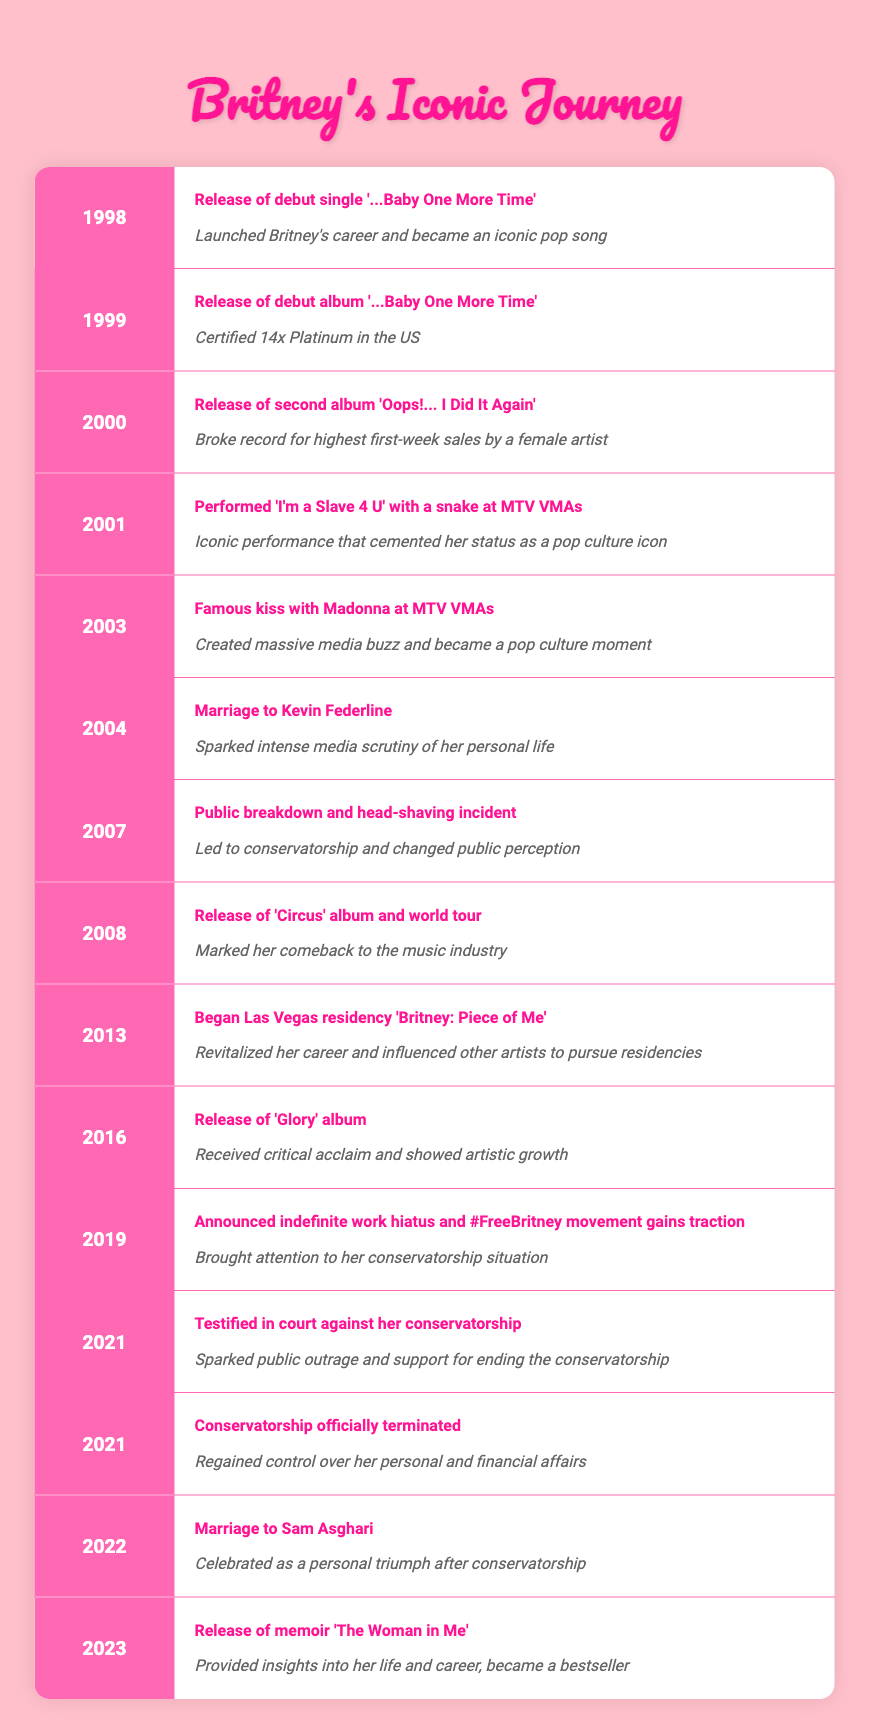What significant event marked the beginning of Britney Spears' career? The table shows that the release of her debut single '...Baby One More Time' in 1998 is cited as the event that launched her career. This information is contained in the first row of the timeline.
Answer: Release of debut single '...Baby One More Time' What was the year when Britney released her second album? According to the timeline, Britney released her second album 'Oops!... I Did It Again' in 2000, which can be found in the third row of the table.
Answer: 2000 Did Britney Spears perform live at the MTV VMAs in 2001? The table indicates that Britney Spears performed 'I'm a Slave 4 U' with a snake at the MTV VMAs in 2001, confirming that she did perform live that year.
Answer: Yes What was the impact of the famous kiss with Madonna in 2003? In the timeline, the impact of the famous kiss with Madonna at the MTV VMAs in 2003 is stated as creating massive media buzz and becoming a notable pop culture moment. This is found in the fifth row.
Answer: Created massive media buzz and became a pop culture moment How many years passed between the release of 'Circus' and the beginning of her Las Vegas residency? 'Circus' was released in 2008 and the Las Vegas residency 'Britney: Piece of Me' began in 2013. To find the difference: 2013 - 2008 = 5 years. Therefore, the number of years that passed is five.
Answer: 5 What event occurred in 2021 that sparked public outrage? The timeline lists two events in 2021: Britney testifying against her conservatorship and the conservatorship being officially terminated. Both events caused public outrage, but the testimony specifically sparked significant public support for ending the conservatorship. This is noted in the twelfth row.
Answer: Testified in court against her conservatorship In what year did Britney's conservatorship officially end? The table shows that Britney's conservatorship officially terminated in 2021, with this information recorded in the thirteenth row of the timeline.
Answer: 2021 Which album was released just before Britney announced her indefinite work hiatus? The timeline specifies that the album 'Glory' was released in 2016 and that she announced her indefinite work hiatus in 2019. Therefore, the album released just before the hiatus was 'Glory'.
Answer: 'Glory' What is the impact of Britney's marriage to Sam Asghari in 2022? According to the timeline, her marriage to Sam Asghari in 2022 is celebrated as a personal triumph after her conservatorship, as stated in the fourteenth row.
Answer: Celebrated as a personal triumph after conservatorship 